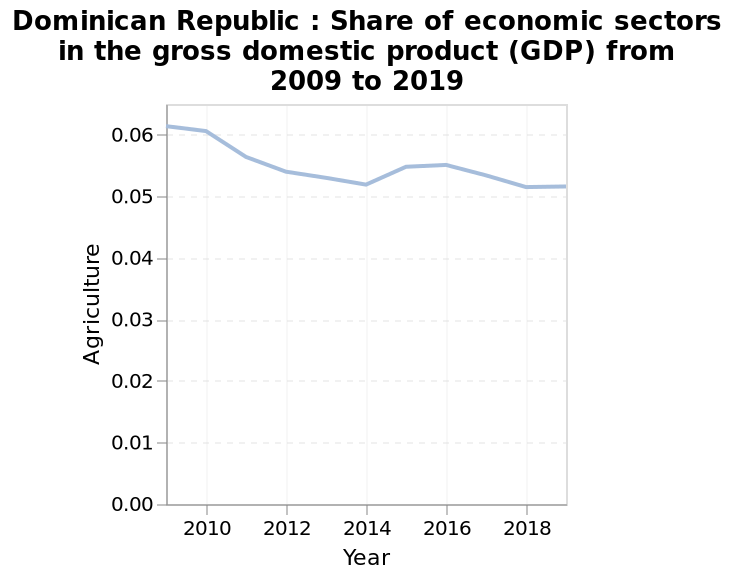<image>
please summary the statistics and relations of the chart Agriculture had a larger share in GDP in 2009, bumpily decreasing from around 0.06 to around 0.05. Offer a thorough analysis of the image. Agriculture had its highest share of GDP - 0.6 - in 2009. In the following years, the share of agriculture dropped l, briefly increasing again in 2014-15 before dropping again and being at its lowest in 2019 (just over 0.5). please describe the details of the chart Dominican Republic : Share of economic sectors in the gross domestic product (GDP) from 2009 to 2019 is a line chart. The x-axis measures Year with linear scale of range 2010 to 2018 while the y-axis measures Agriculture with linear scale with a minimum of 0.00 and a maximum of 0.06. 